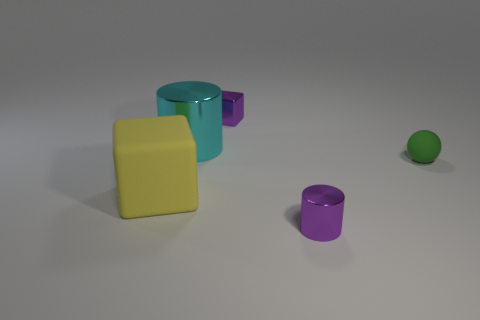Add 3 cyan cylinders. How many objects exist? 8 Subtract all cubes. How many objects are left? 3 Subtract all yellow cubes. How many cubes are left? 1 Add 2 tiny cyan things. How many tiny cyan things exist? 2 Subtract 1 yellow cubes. How many objects are left? 4 Subtract 1 balls. How many balls are left? 0 Subtract all yellow cylinders. Subtract all purple balls. How many cylinders are left? 2 Subtract all yellow blocks. How many cyan spheres are left? 0 Subtract all tiny gray shiny balls. Subtract all tiny purple cylinders. How many objects are left? 4 Add 4 tiny metal cubes. How many tiny metal cubes are left? 5 